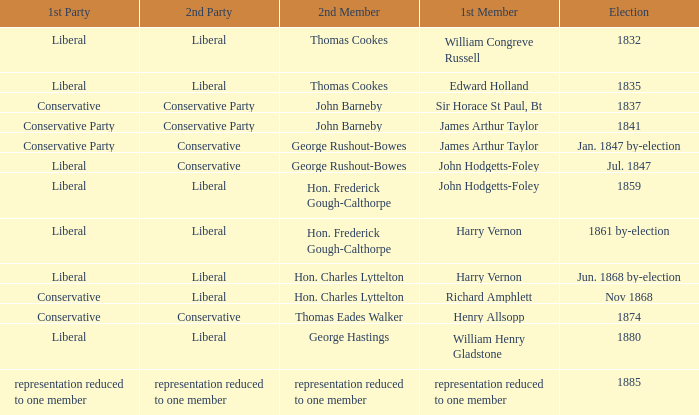Can you parse all the data within this table? {'header': ['1st Party', '2nd Party', '2nd Member', '1st Member', 'Election'], 'rows': [['Liberal', 'Liberal', 'Thomas Cookes', 'William Congreve Russell', '1832'], ['Liberal', 'Liberal', 'Thomas Cookes', 'Edward Holland', '1835'], ['Conservative', 'Conservative Party', 'John Barneby', 'Sir Horace St Paul, Bt', '1837'], ['Conservative Party', 'Conservative Party', 'John Barneby', 'James Arthur Taylor', '1841'], ['Conservative Party', 'Conservative', 'George Rushout-Bowes', 'James Arthur Taylor', 'Jan. 1847 by-election'], ['Liberal', 'Conservative', 'George Rushout-Bowes', 'John Hodgetts-Foley', 'Jul. 1847'], ['Liberal', 'Liberal', 'Hon. Frederick Gough-Calthorpe', 'John Hodgetts-Foley', '1859'], ['Liberal', 'Liberal', 'Hon. Frederick Gough-Calthorpe', 'Harry Vernon', '1861 by-election'], ['Liberal', 'Liberal', 'Hon. Charles Lyttelton', 'Harry Vernon', 'Jun. 1868 by-election'], ['Conservative', 'Liberal', 'Hon. Charles Lyttelton', 'Richard Amphlett', 'Nov 1868'], ['Conservative', 'Conservative', 'Thomas Eades Walker', 'Henry Allsopp', '1874'], ['Liberal', 'Liberal', 'George Hastings', 'William Henry Gladstone', '1880'], ['representation reduced to one member', 'representation reduced to one member', 'representation reduced to one member', 'representation reduced to one member', '1885']]} What was the 2nd Party when its 2nd Member was George Rushout-Bowes, and the 1st Party was Liberal? Conservative. 